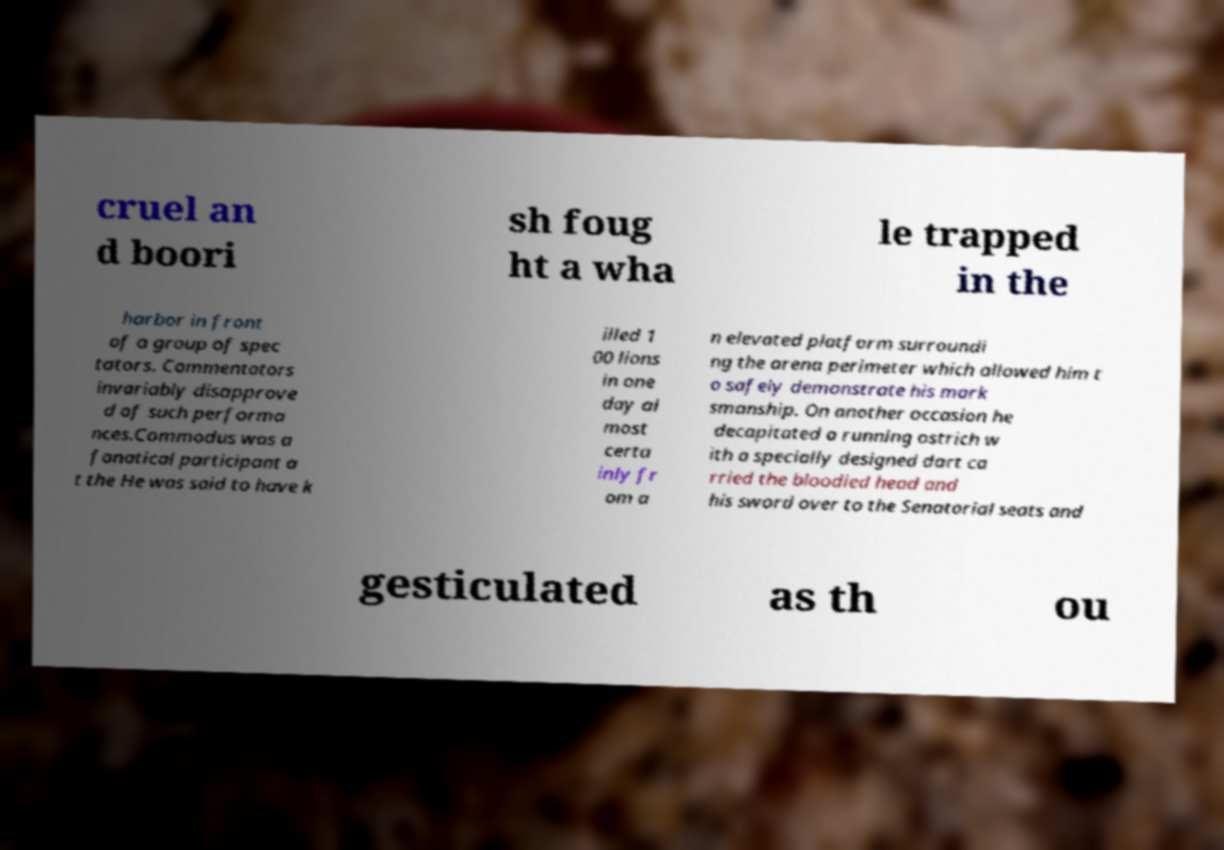Could you extract and type out the text from this image? cruel an d boori sh foug ht a wha le trapped in the harbor in front of a group of spec tators. Commentators invariably disapprove d of such performa nces.Commodus was a fanatical participant a t the He was said to have k illed 1 00 lions in one day al most certa inly fr om a n elevated platform surroundi ng the arena perimeter which allowed him t o safely demonstrate his mark smanship. On another occasion he decapitated a running ostrich w ith a specially designed dart ca rried the bloodied head and his sword over to the Senatorial seats and gesticulated as th ou 